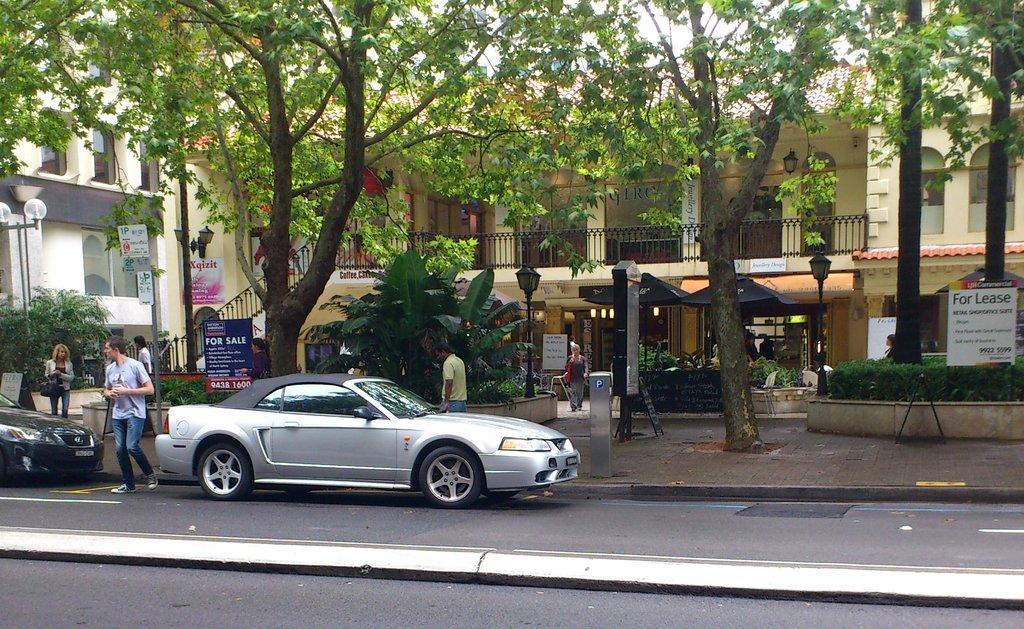Describe this image in one or two sentences. In this image we can see cars on the road and there are people. In the background there are tents, buildings, poles, boards, trees and sky. We can see hedges. 